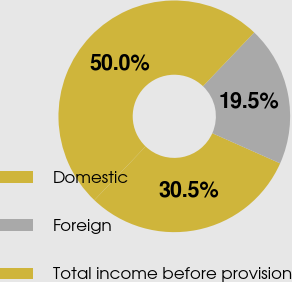<chart> <loc_0><loc_0><loc_500><loc_500><pie_chart><fcel>Domestic<fcel>Foreign<fcel>Total income before provision<nl><fcel>30.46%<fcel>19.54%<fcel>50.0%<nl></chart> 